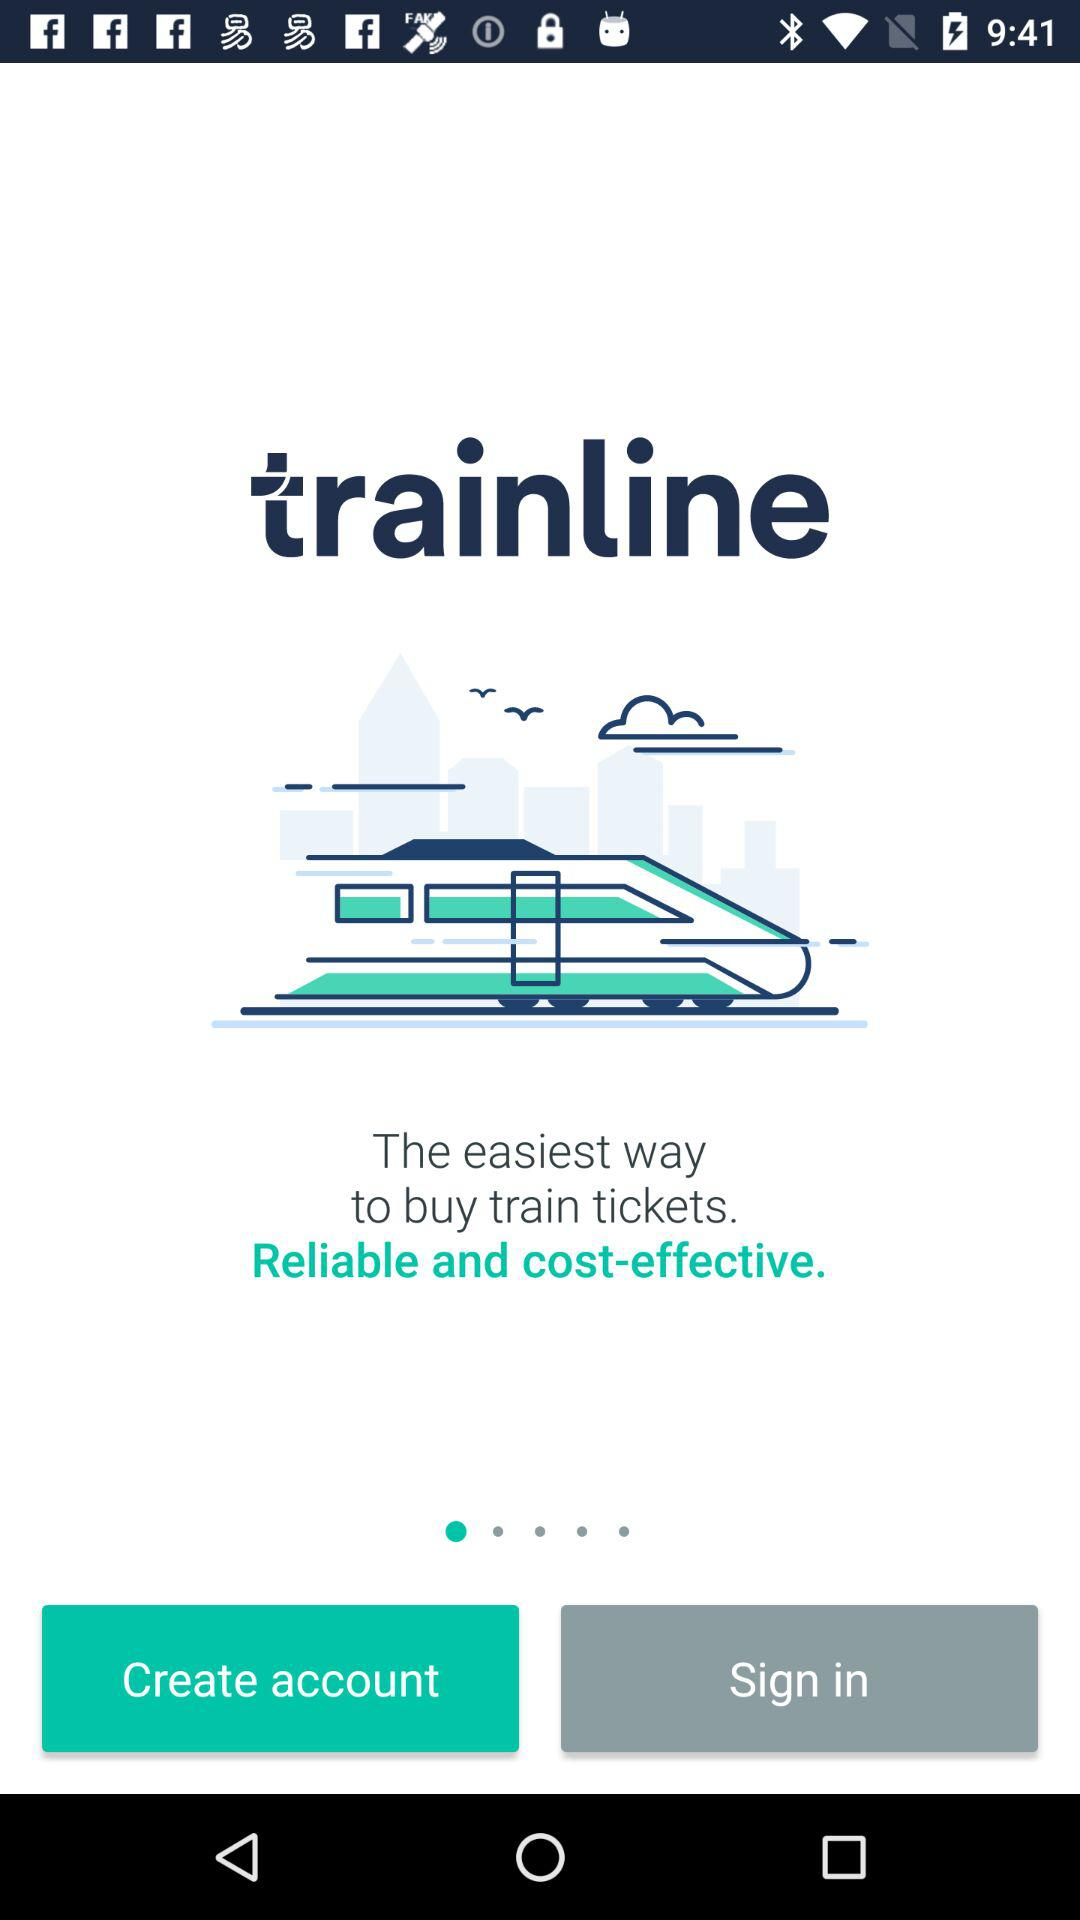What is the app name? The app name is "trainline". 